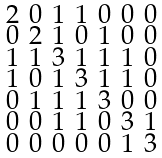<formula> <loc_0><loc_0><loc_500><loc_500>\begin{smallmatrix} 2 & 0 & 1 & 1 & 0 & 0 & 0 \\ 0 & 2 & 1 & 0 & 1 & 0 & 0 \\ 1 & 1 & 3 & 1 & 1 & 1 & 0 \\ 1 & 0 & 1 & 3 & 1 & 1 & 0 \\ 0 & 1 & 1 & 1 & 3 & 0 & 0 \\ 0 & 0 & 1 & 1 & 0 & 3 & 1 \\ 0 & 0 & 0 & 0 & 0 & 1 & 3 \end{smallmatrix}</formula> 